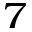<formula> <loc_0><loc_0><loc_500><loc_500>^ { 7 }</formula> 